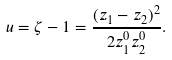<formula> <loc_0><loc_0><loc_500><loc_500>u = \zeta - 1 = \frac { ( z _ { 1 } - z _ { 2 } ) ^ { 2 } } { 2 z _ { 1 } ^ { 0 } z _ { 2 } ^ { 0 } } .</formula> 